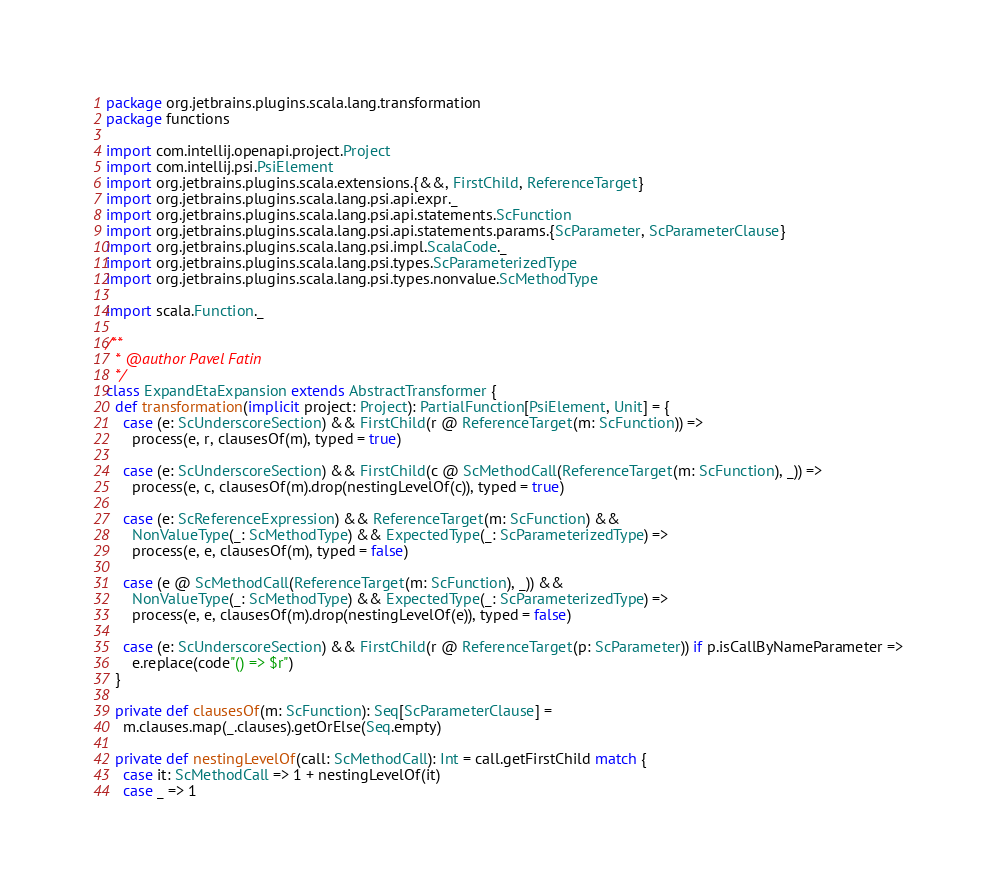<code> <loc_0><loc_0><loc_500><loc_500><_Scala_>package org.jetbrains.plugins.scala.lang.transformation
package functions

import com.intellij.openapi.project.Project
import com.intellij.psi.PsiElement
import org.jetbrains.plugins.scala.extensions.{&&, FirstChild, ReferenceTarget}
import org.jetbrains.plugins.scala.lang.psi.api.expr._
import org.jetbrains.plugins.scala.lang.psi.api.statements.ScFunction
import org.jetbrains.plugins.scala.lang.psi.api.statements.params.{ScParameter, ScParameterClause}
import org.jetbrains.plugins.scala.lang.psi.impl.ScalaCode._
import org.jetbrains.plugins.scala.lang.psi.types.ScParameterizedType
import org.jetbrains.plugins.scala.lang.psi.types.nonvalue.ScMethodType

import scala.Function._

/**
  * @author Pavel Fatin
  */
class ExpandEtaExpansion extends AbstractTransformer {
  def transformation(implicit project: Project): PartialFunction[PsiElement, Unit] = {
    case (e: ScUnderscoreSection) && FirstChild(r @ ReferenceTarget(m: ScFunction)) =>
      process(e, r, clausesOf(m), typed = true)

    case (e: ScUnderscoreSection) && FirstChild(c @ ScMethodCall(ReferenceTarget(m: ScFunction), _)) =>
      process(e, c, clausesOf(m).drop(nestingLevelOf(c)), typed = true)

    case (e: ScReferenceExpression) && ReferenceTarget(m: ScFunction) &&
      NonValueType(_: ScMethodType) && ExpectedType(_: ScParameterizedType) =>
      process(e, e, clausesOf(m), typed = false)

    case (e @ ScMethodCall(ReferenceTarget(m: ScFunction), _)) &&
      NonValueType(_: ScMethodType) && ExpectedType(_: ScParameterizedType) =>
      process(e, e, clausesOf(m).drop(nestingLevelOf(e)), typed = false)

    case (e: ScUnderscoreSection) && FirstChild(r @ ReferenceTarget(p: ScParameter)) if p.isCallByNameParameter =>
      e.replace(code"() => $r")
  }

  private def clausesOf(m: ScFunction): Seq[ScParameterClause] =
    m.clauses.map(_.clauses).getOrElse(Seq.empty)

  private def nestingLevelOf(call: ScMethodCall): Int = call.getFirstChild match {
    case it: ScMethodCall => 1 + nestingLevelOf(it)
    case _ => 1</code> 